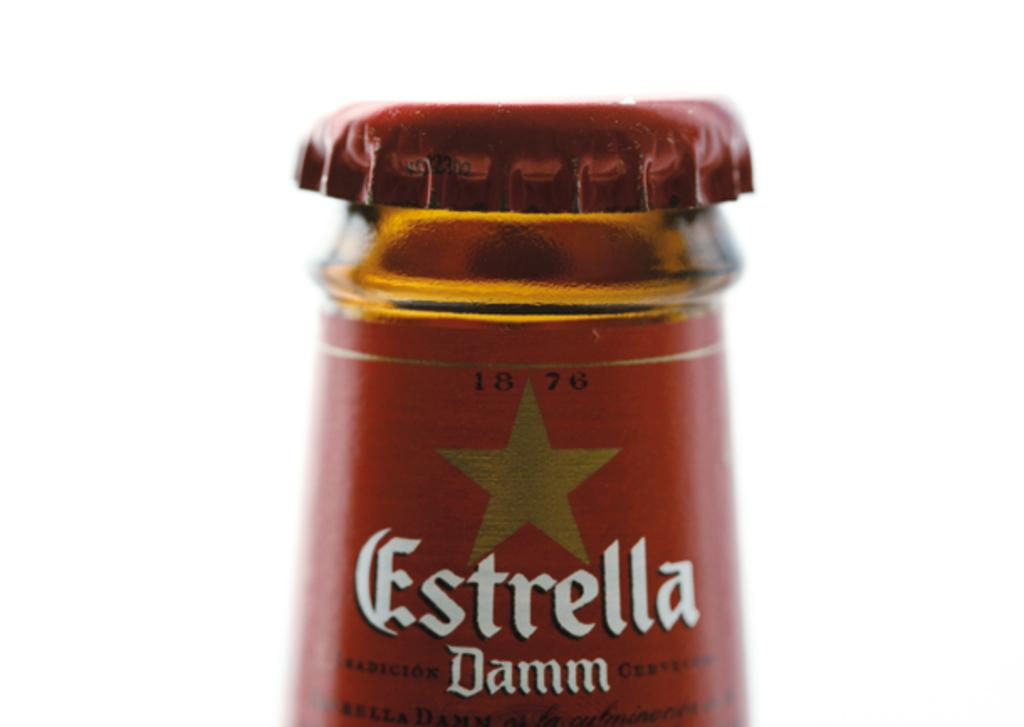<image>
Create a compact narrative representing the image presented. A close up of the top of a bottle of Estrella. 